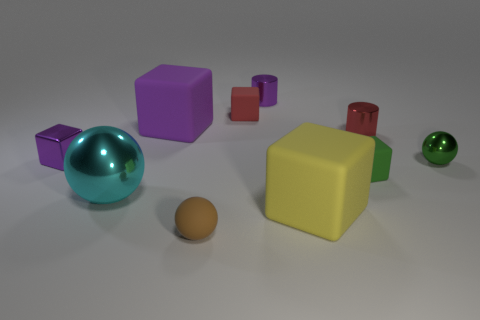What number of things are either purple objects that are in front of the red metallic cylinder or big things that are to the left of the yellow matte cube?
Provide a short and direct response. 3. There is a cylinder that is to the left of the tiny matte block in front of the big purple matte object; what is its color?
Offer a terse response. Purple. The sphere that is made of the same material as the yellow block is what color?
Make the answer very short. Brown. What number of small shiny cylinders are the same color as the tiny metal cube?
Give a very brief answer. 1. What number of things are either blue metal cylinders or blocks?
Offer a terse response. 5. There is a red rubber thing that is the same size as the red shiny thing; what shape is it?
Offer a terse response. Cube. How many objects are in front of the large yellow object and behind the small green matte cube?
Keep it short and to the point. 0. What is the ball that is behind the cyan sphere made of?
Your answer should be very brief. Metal. What is the size of the red block that is made of the same material as the large purple object?
Offer a terse response. Small. Is the size of the metal sphere that is right of the big purple cube the same as the metallic ball to the left of the purple cylinder?
Ensure brevity in your answer.  No. 